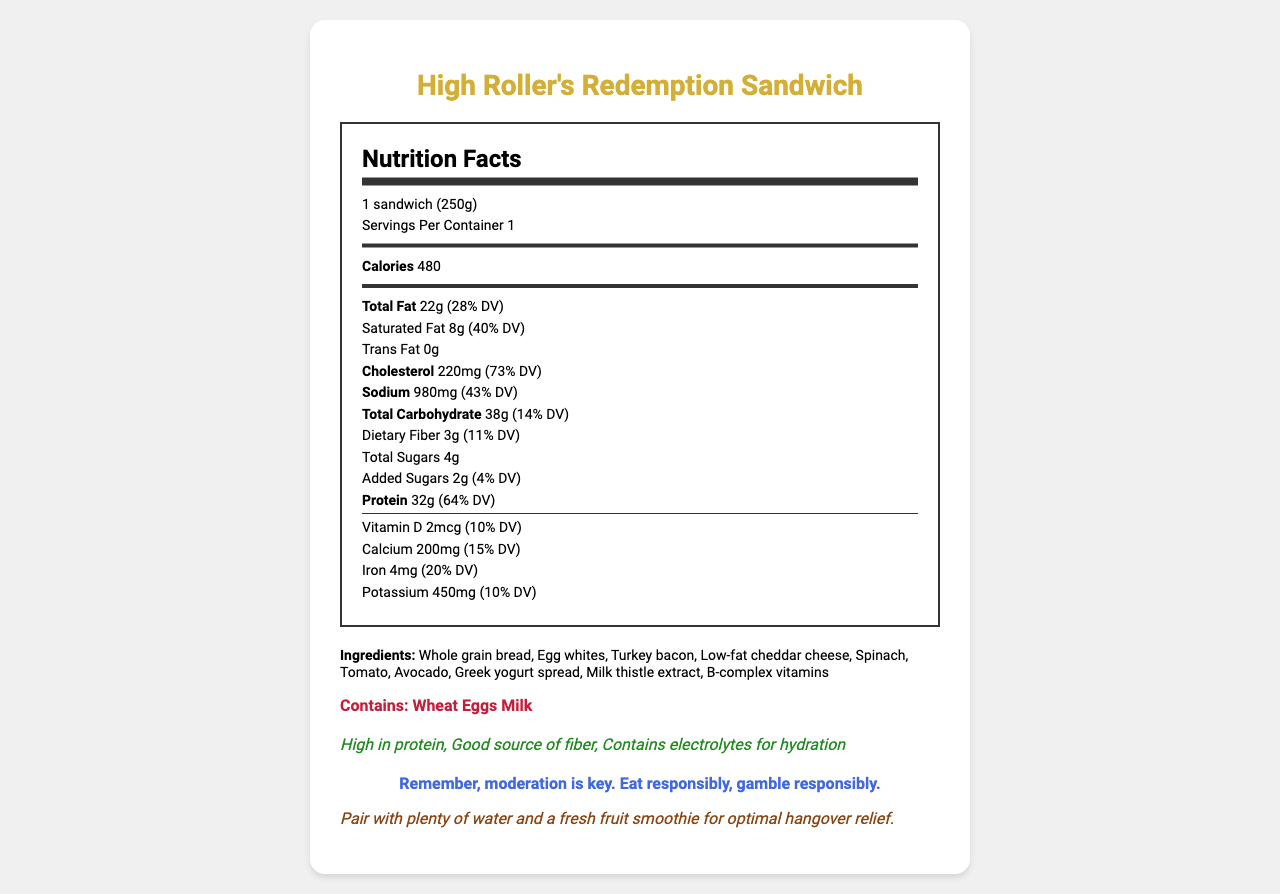what is the serving size of the High Roller's Redemption Sandwich? The serving size is specified as 1 sandwich (250g) in the document.
Answer: 1 sandwich (250g) how many calories are in one serving? The document states that there are 480 calories in one serving.
Answer: 480 calories what is the amount of protein in the sandwich? According to the Nutrition Facts, the sandwich contains 32g of protein.
Answer: 32g what are the main ingredients listed? The ingredients section lists these as the main ingredients.
Answer: Whole grain bread, Egg whites, Turkey bacon, Low-fat cheddar cheese, Spinach, Tomato, Avocado, Greek yogurt spread, Milk thistle extract, B-complex vitamins how much sodium is in the sandwich? The document specifies that there are 980mg of sodium in the sandwich.
Answer: 980mg what percentage of the daily value is the saturated fat content? A. 20% B. 30% C. 40% D. 50% The saturated fat content is listed as 8g, which is 40% of the daily value.
Answer: C. 40% which of the following is a listed allergen in the sandwich? A. Soy B. Wheat C. Soybeans D. Peanuts "Wheat" is mentioned as an allergen in the document.
Answer: B. Wheat does the sandwich contain any added sugars? The document lists 2g of added sugars.
Answer: Yes can the level of Vitamin C be determined from the document? The document does not contain information about the level of Vitamin C.
Answer: Cannot be determined summarize the main information provided in the document The document provides comprehensive nutritional information, ingredients, and additional messages for responsible eating and recovery.
Answer: The document is a detailed Nutritional Facts Label for "High Roller's Redemption Sandwich," a protein-rich, hangover-recovery breakfast sandwich. It includes nutritional details such as calories, fat, protein, and other nutrients, along with ingredients, allergens, health claims, a responsible gambling message, and a recovery tip. what is the serving size in grams? The serving size is provided as "1 sandwich (250g)", so the serving size in grams is 250g.
Answer: 250g what health claims are made about the sandwich? The health claims section lists these benefits specifically.
Answer: High in protein, Good source of fiber, Contains electrolytes for hydration how much dietary fiber does the sandwich contain? The document lists 3g of dietary fiber in the sandwich.
Answer: 3g does the sandwich contain any trans fat? The document shows that the sandwich contains 0g of trans fat.
Answer: No what should you pair with the sandwich for optimal hangover relief? The recovery tip suggests pairing it with plenty of water and a fresh fruit smoothie for optimal hangover relief.
Answer: Plenty of water and a fresh fruit smoothie 